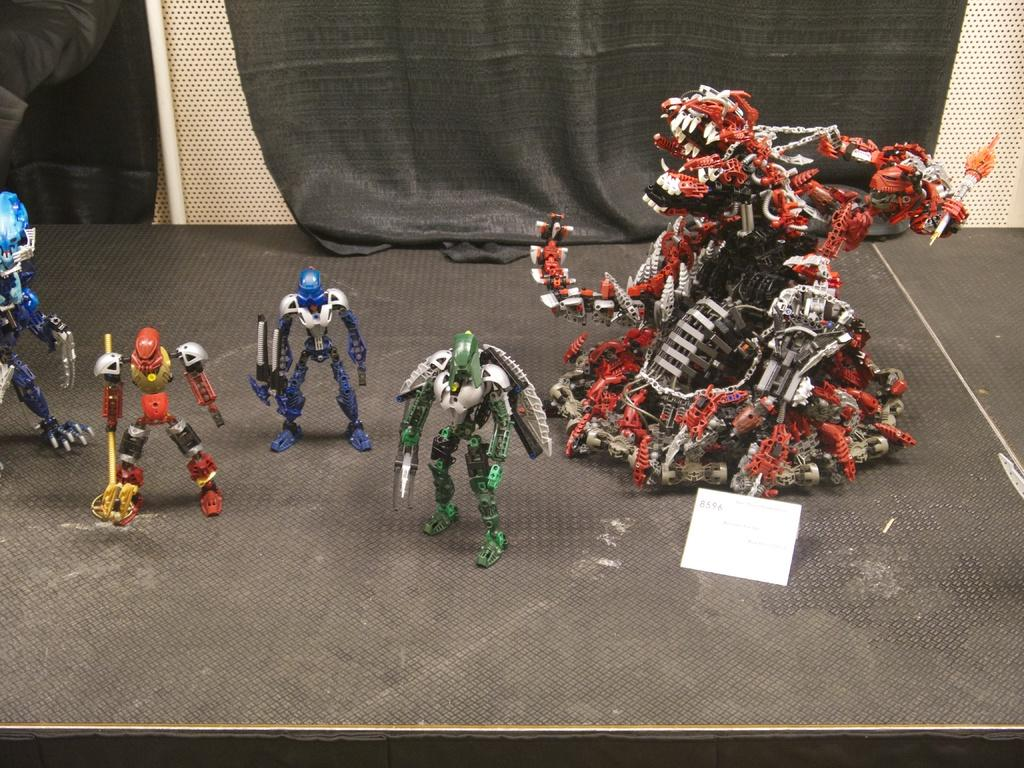What type of toys are on the platform in the image? There are toy robots on a platform in the image. What other object can be seen in the image besides the toy robots? There is a paper in the image. What can be seen in the background of the image? There is a cloth visible in the background of the image. What type of hydrant is present in the image? There is no hydrant present in the image. What type of air is visible in the image? The image does not depict any specific type of air; it is simply a photograph of objects. 